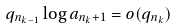Convert formula to latex. <formula><loc_0><loc_0><loc_500><loc_500>q _ { n _ { k - 1 } } \log a _ { n _ { k } + 1 } = o ( q _ { n _ { k } } )</formula> 